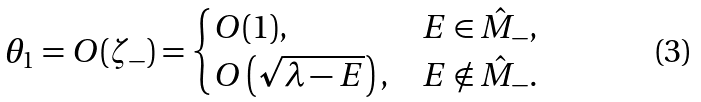Convert formula to latex. <formula><loc_0><loc_0><loc_500><loc_500>\theta _ { 1 } = O ( \zeta _ { - } ) = \begin{cases} O ( 1 ) , & E \in \hat { M } _ { - } , \\ O \left ( \sqrt { \lambda - E } \right ) , & E \notin \hat { M } _ { - } . \end{cases}</formula> 